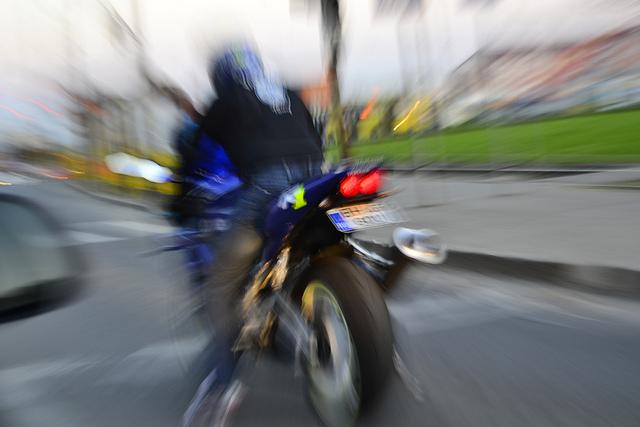What is the red object?
Keep it brief. Tail light. Was a filter used to take this photo?
Give a very brief answer. Yes. What color is the rider's jacket?
Write a very short answer. Black. 